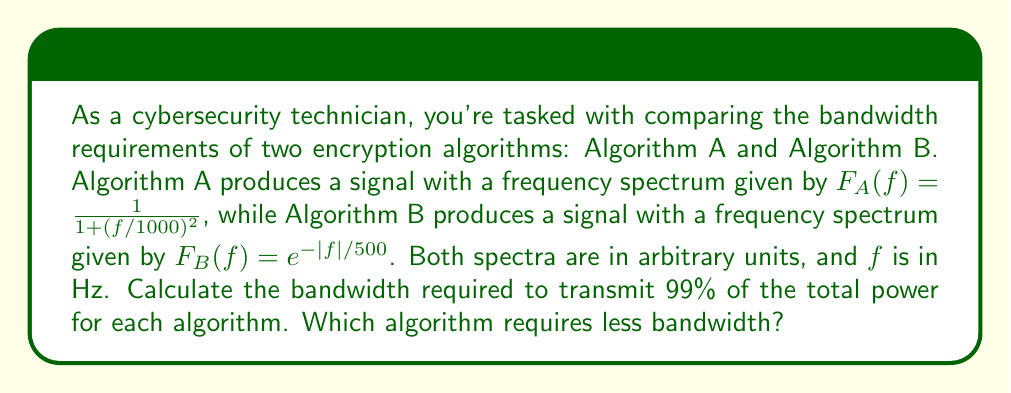Could you help me with this problem? To solve this problem, we'll use Fourier analysis concepts and the given frequency spectra. We'll follow these steps for each algorithm:

1. Calculate the total power of the signal.
2. Find the bandwidth that contains 99% of the total power.
3. Compare the results.

For Algorithm A:

1. Total power:
   $$P_A = \int_{-\infty}^{\infty} |F_A(f)|^2 df = \int_{-\infty}^{\infty} \frac{1}{(1 + (f/1000)^2)^2} df$$
   This integral evaluates to:
   $$P_A = \frac{\pi}{1000} = 0.00314159$$

2. To find the bandwidth containing 99% of the power, we need to solve:
   $$0.99 P_A = \int_{-B_A}^{B_A} \frac{1}{(1 + (f/1000)^2)^2} df$$
   This leads to the equation:
   $$0.99 \cdot \frac{\pi}{1000} = \frac{B_A}{1000} \cdot \frac{\pi/2}{1 + (B_A/1000)^2}$$
   Solving numerically, we get:
   $$B_A \approx 4472 \text{ Hz}$$

For Algorithm B:

1. Total power:
   $$P_B = \int_{-\infty}^{\infty} |F_B(f)|^2 df = \int_{-\infty}^{\infty} e^{-2|f|/500} df = 500$$

2. To find the bandwidth containing 99% of the power, we need to solve:
   $$0.99 P_B = \int_{-B_B}^{B_B} e^{-2|f|/500} df$$
   This leads to the equation:
   $$0.99 \cdot 500 = 500 \cdot (1 - e^{-2B_B/500})$$
   Solving numerically, we get:
   $$B_B \approx 1151 \text{ Hz}$$

Comparing the results, we see that Algorithm B requires less bandwidth to transmit 99% of its total power.
Answer: Algorithm B requires less bandwidth, with approximately 1151 Hz compared to Algorithm A's 4472 Hz. 